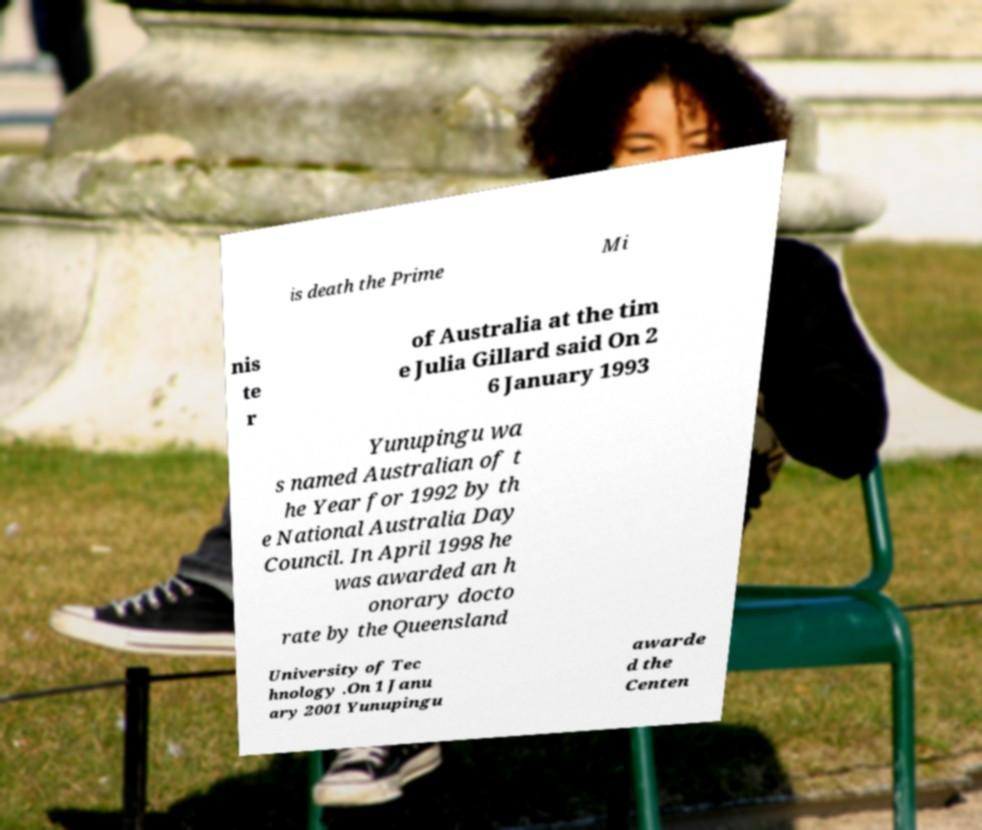What messages or text are displayed in this image? I need them in a readable, typed format. is death the Prime Mi nis te r of Australia at the tim e Julia Gillard said On 2 6 January 1993 Yunupingu wa s named Australian of t he Year for 1992 by th e National Australia Day Council. In April 1998 he was awarded an h onorary docto rate by the Queensland University of Tec hnology .On 1 Janu ary 2001 Yunupingu awarde d the Centen 